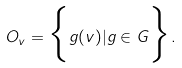<formula> <loc_0><loc_0><loc_500><loc_500>O _ { v } = \Big { \{ } g ( v ) | g \in G \Big { \} } .</formula> 